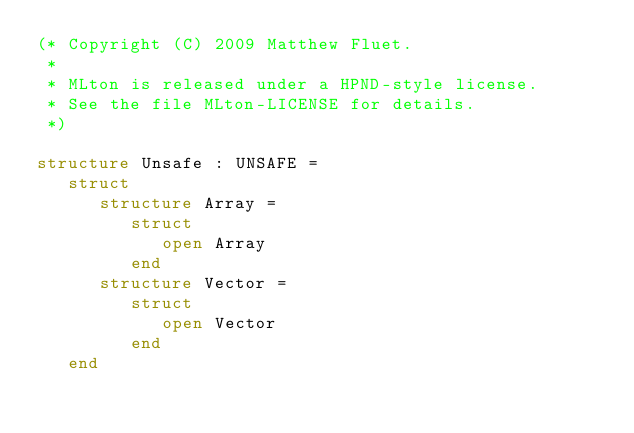Convert code to text. <code><loc_0><loc_0><loc_500><loc_500><_SML_>(* Copyright (C) 2009 Matthew Fluet.
 *
 * MLton is released under a HPND-style license.
 * See the file MLton-LICENSE for details.
 *)

structure Unsafe : UNSAFE =
   struct
      structure Array =
         struct
            open Array
         end
      structure Vector =
         struct
            open Vector
         end
   end</code> 